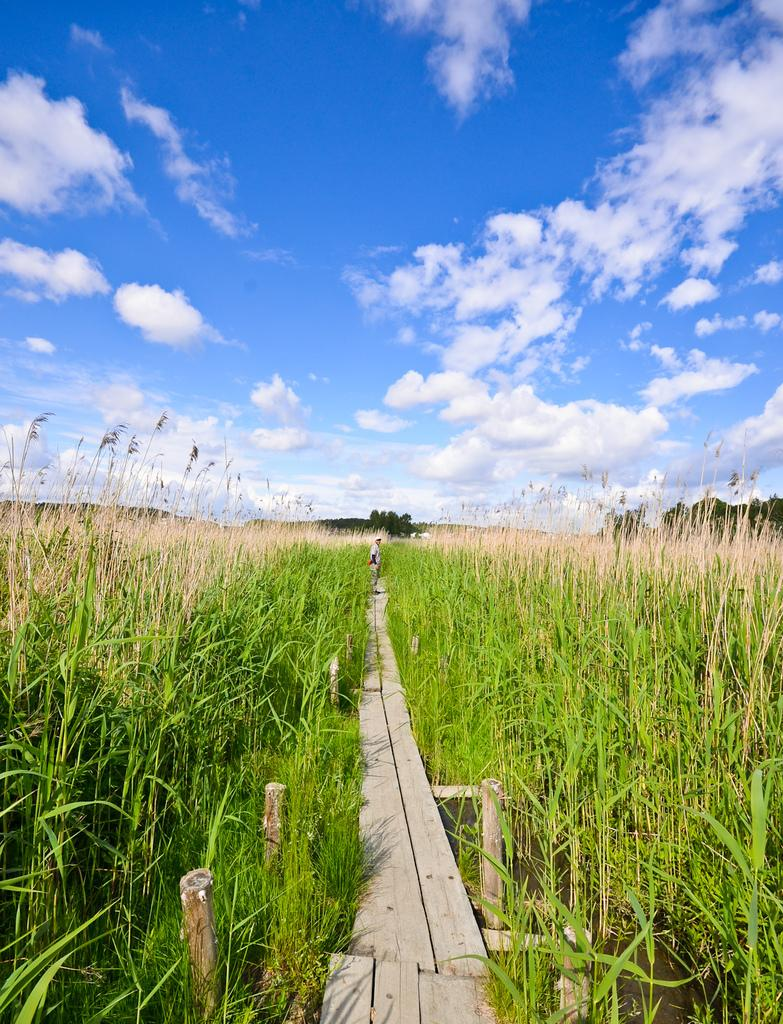What type of vegetation can be seen in the image? There are crops in the image. What kind of pathway is present in the image? There is a wooden pathway in the image. Can you describe the person in the image? There is a person standing in the image. What can be seen in the background of the image? There are trees in the background of the image. What is visible in the sky in the image? There are clouds in the sky in the image. What type of knee brace is the person wearing in the image? There is no indication of a knee brace or any clothing on the person in the image. What attraction is nearby that the person might be visiting? There is no information about any nearby attractions or the person's purpose in the image. 